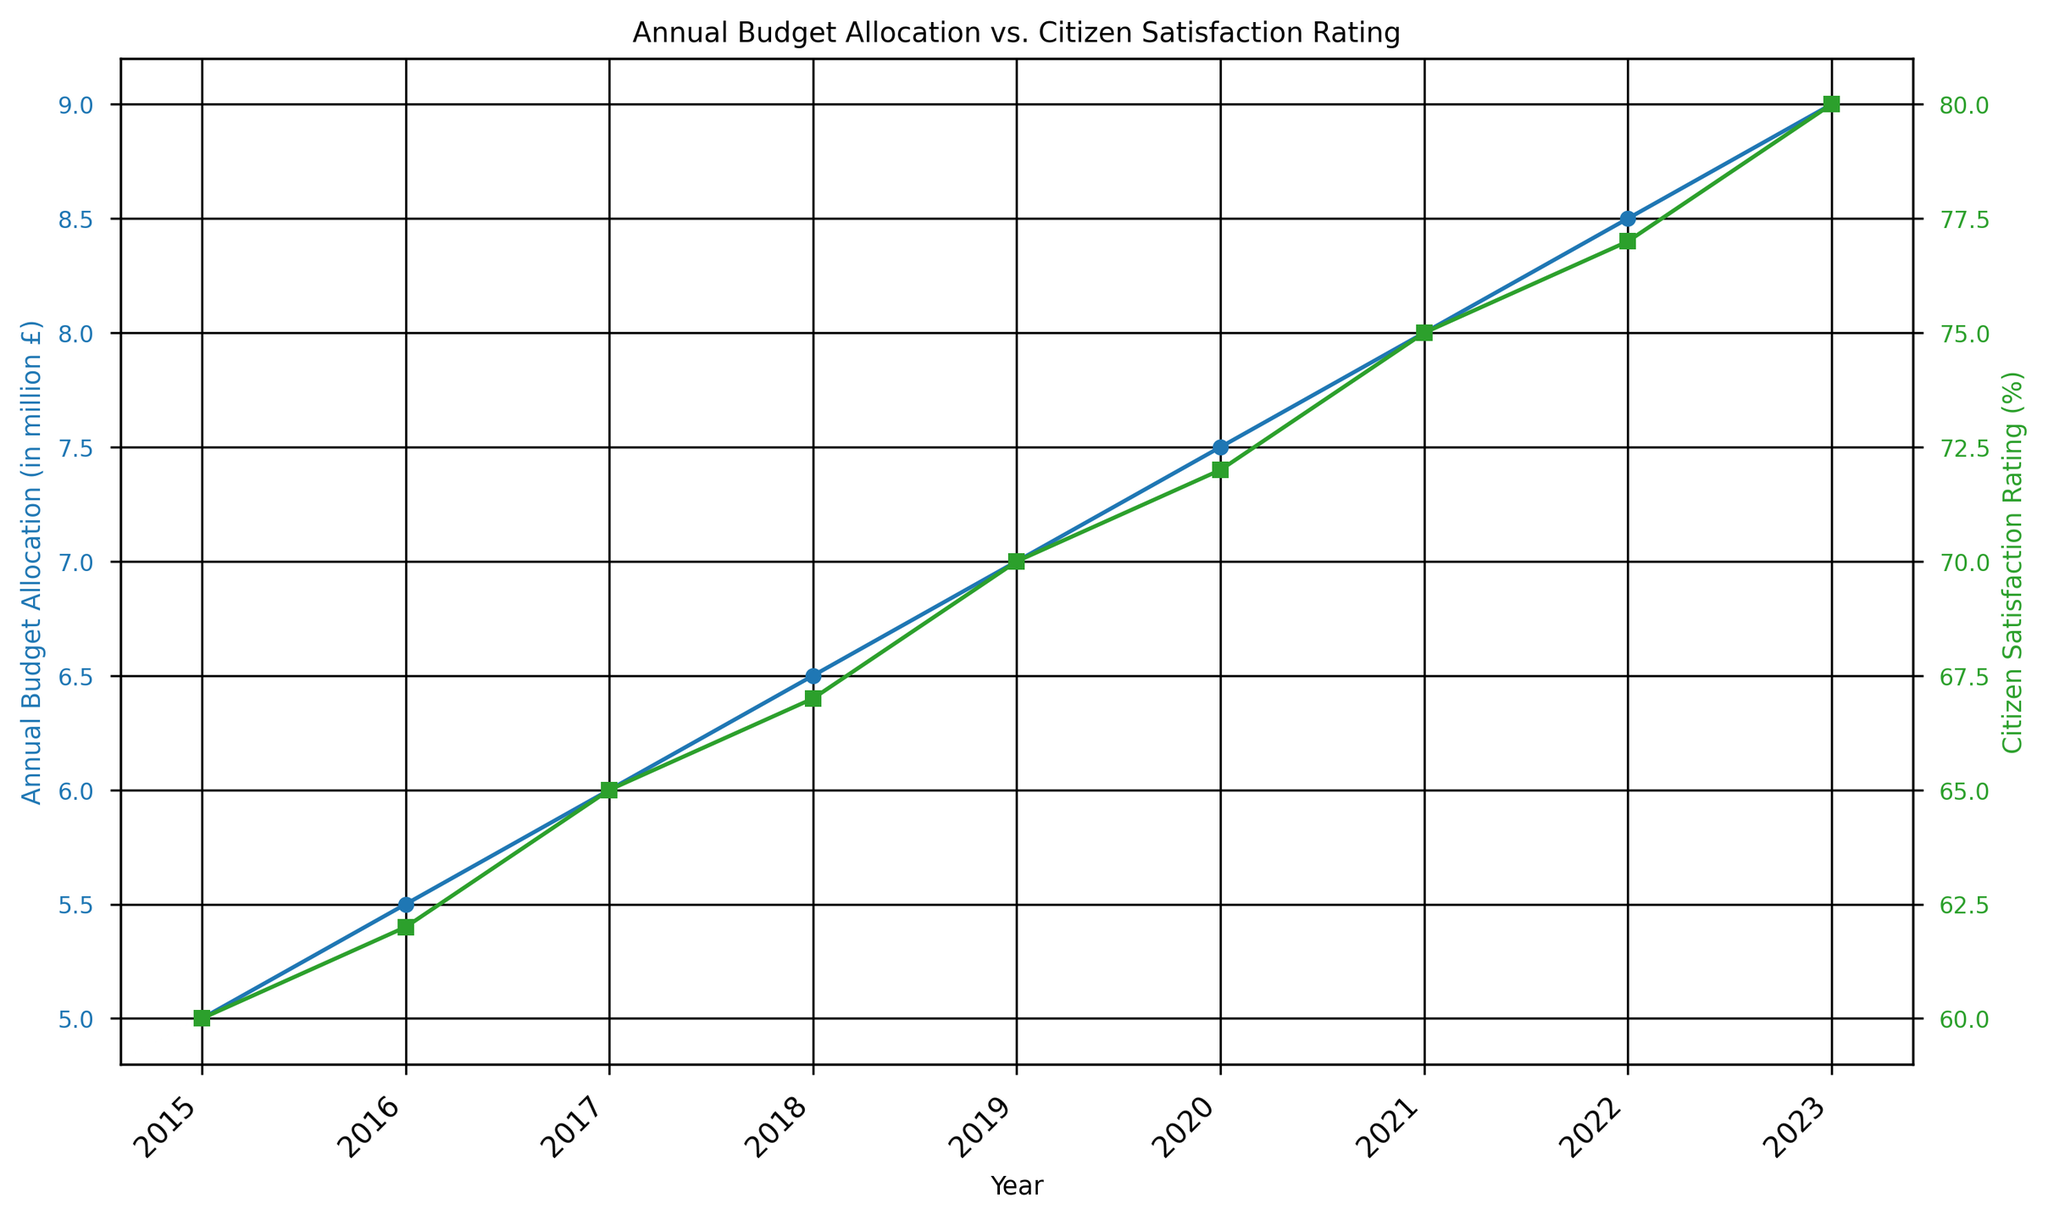What's the total budget allocation over the years shown in the figure? Sum up the annual budget allocations from 2015 to 2023: 5.0 + 5.5 + 6.0 + 6.5 + 7.0 + 7.5 + 8.0 + 8.5 + 9.0 = 63.0 million £
Answer: 63.0 million £ Between which two consecutive years did the citizen satisfaction rating increase the most? Calculate the yearly increase: 2015-2016 (2%), 2016-2017 (3%), 2017-2018 (2%), 2018-2019 (3%), 2019-2020 (2%), 2020-2021 (3%), 2021-2022 (2%), 2022-2023 (3%). The largest increase is from 2016 to 2017, 2018 to 2019, 2020 to 2021, and 2022 to 2023, all 3%.
Answer: 2016-2017, 2018-2019, 2020-2021, 2022-2023 In which year did the citizen satisfaction rating reach 70% for the first time? Identify the year where the satisfaction rating first equals or exceeds 70%. The figure shows 2019 is 70%.
Answer: 2019 What's the difference in budget allocation between the years 2015 and 2023? Subtract the budget allocation of 2015 from that of 2023: 9.0 - 5.0 = 4.0 million £
Answer: 4.0 million £ Which year had the equal budget allocation increase as that of the increase from 2019 to 2020? Calculate the increase for each pair of consecutive years. The increase from 2019 (7.0) to 2020 (7.5) is 0.5 million £. Compare all pairs: 2015 to 2016 (0.5), 2016 to 2017 (0.5), 2017 to 2018 (0.5), 2018 to 2019 (0.5), 2019 to 2020 (0.5), 2020 to 2021 (0.5), 2021 to 2022 (0.5), 2022 to 2023 (0.5). All increases are equal across all years.
Answer: 2015-2016, 2016-2017, 2017-2018, 2018-2019, 2019-2020, 2020-2021, 2021-2022, 2022-2023 What was the average citizen satisfaction rating from 2015 to 2023? Sum the satisfaction ratings and divide by the number of years: (60 + 62 + 65 + 67 + 70 + 72 + 75 + 77 + 80) / 9 ≈ 69.8%
Answer: 69.8% How does the color of the lines differentiate the data series? The plot uses color to differentiate between the series: the blue line for Annual Budget Allocation and the green line for Citizen Satisfaction Rating.
Answer: Blue for Budget, Green for Satisfaction Which year marked the transition from below 70% to above 70% citizen satisfaction rating? Look for the year where the rating changes from below 70% to above 70%. It occurs from 2019 (70%) to 2020 (72%).
Answer: 2020 